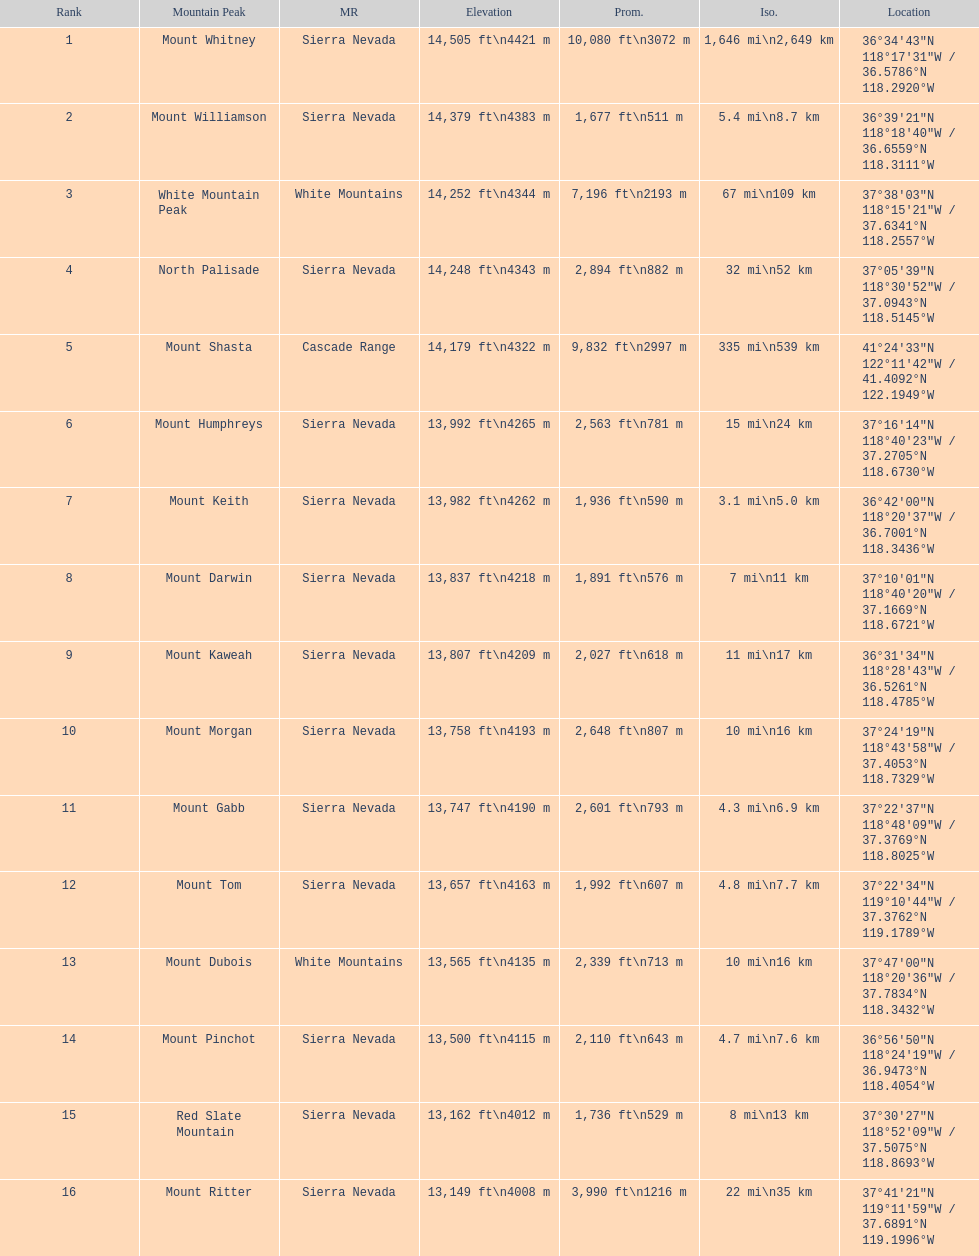What is the tallest peak in the sierra nevadas? Mount Whitney. 